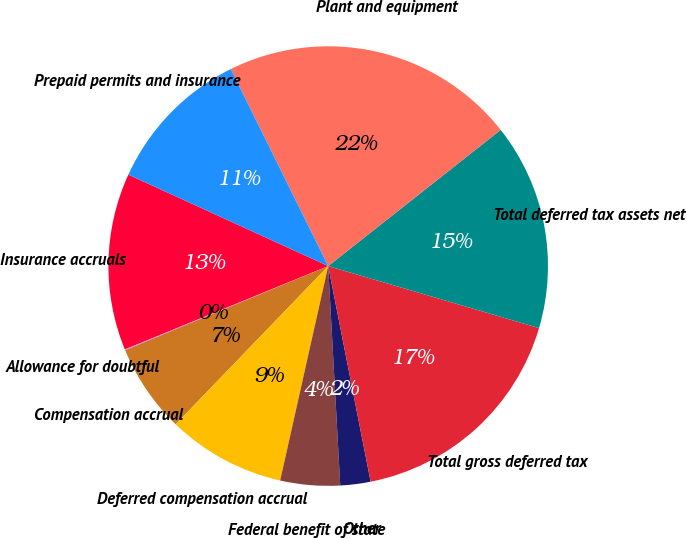<chart> <loc_0><loc_0><loc_500><loc_500><pie_chart><fcel>Insurance accruals<fcel>Allowance for doubtful<fcel>Compensation accrual<fcel>Deferred compensation accrual<fcel>Federal benefit of state<fcel>Other<fcel>Total gross deferred tax<fcel>Total deferred tax assets net<fcel>Plant and equipment<fcel>Prepaid permits and insurance<nl><fcel>13.02%<fcel>0.06%<fcel>6.54%<fcel>8.7%<fcel>4.38%<fcel>2.22%<fcel>17.35%<fcel>15.19%<fcel>21.67%<fcel>10.86%<nl></chart> 